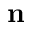<formula> <loc_0><loc_0><loc_500><loc_500>n</formula> 